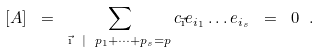<formula> <loc_0><loc_0><loc_500><loc_500>[ A ] \ = \ \sum _ { \vec { \text {\i} } \ | \ p _ { 1 } + \dots + p _ { s } = p } c _ { \vec { \text {\i} } } e _ { i _ { 1 } } \dots e _ { i _ { s } } \ = \ 0 \ .</formula> 